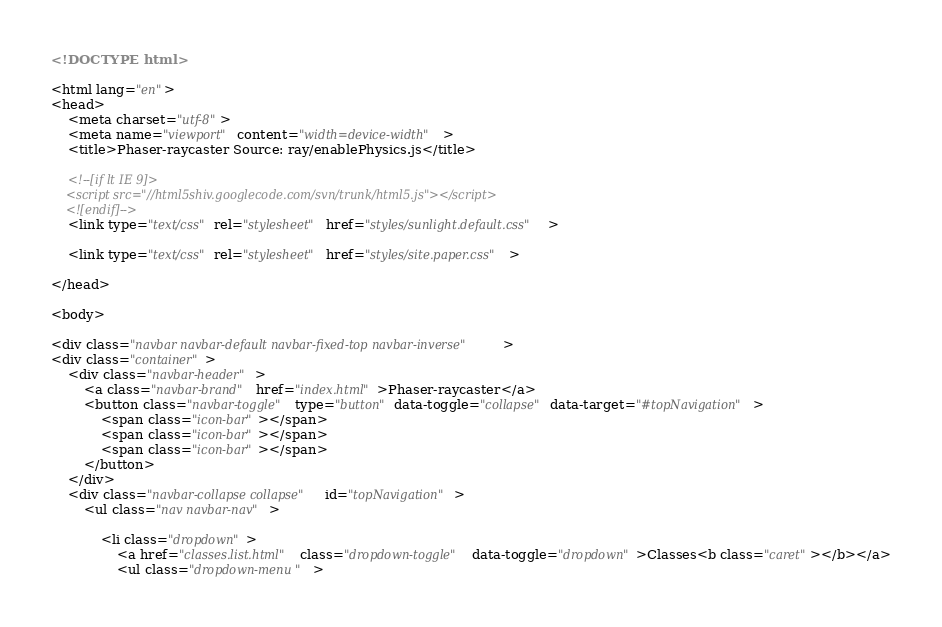Convert code to text. <code><loc_0><loc_0><loc_500><loc_500><_HTML_><!DOCTYPE html>

<html lang="en">
<head>
	<meta charset="utf-8">
	<meta name="viewport" content="width=device-width">
	<title>Phaser-raycaster Source: ray/enablePhysics.js</title>

	<!--[if lt IE 9]>
	<script src="//html5shiv.googlecode.com/svn/trunk/html5.js"></script>
	<![endif]-->
	<link type="text/css" rel="stylesheet" href="styles/sunlight.default.css">

	<link type="text/css" rel="stylesheet" href="styles/site.paper.css">

</head>

<body>

<div class="navbar navbar-default navbar-fixed-top navbar-inverse">
<div class="container">
	<div class="navbar-header">
		<a class="navbar-brand" href="index.html">Phaser-raycaster</a>
		<button class="navbar-toggle" type="button" data-toggle="collapse" data-target="#topNavigation">
			<span class="icon-bar"></span>
			<span class="icon-bar"></span>
			<span class="icon-bar"></span>
        </button>
	</div>
	<div class="navbar-collapse collapse" id="topNavigation">
		<ul class="nav navbar-nav">
			
			<li class="dropdown">
				<a href="classes.list.html" class="dropdown-toggle" data-toggle="dropdown">Classes<b class="caret"></b></a>
				<ul class="dropdown-menu "></code> 